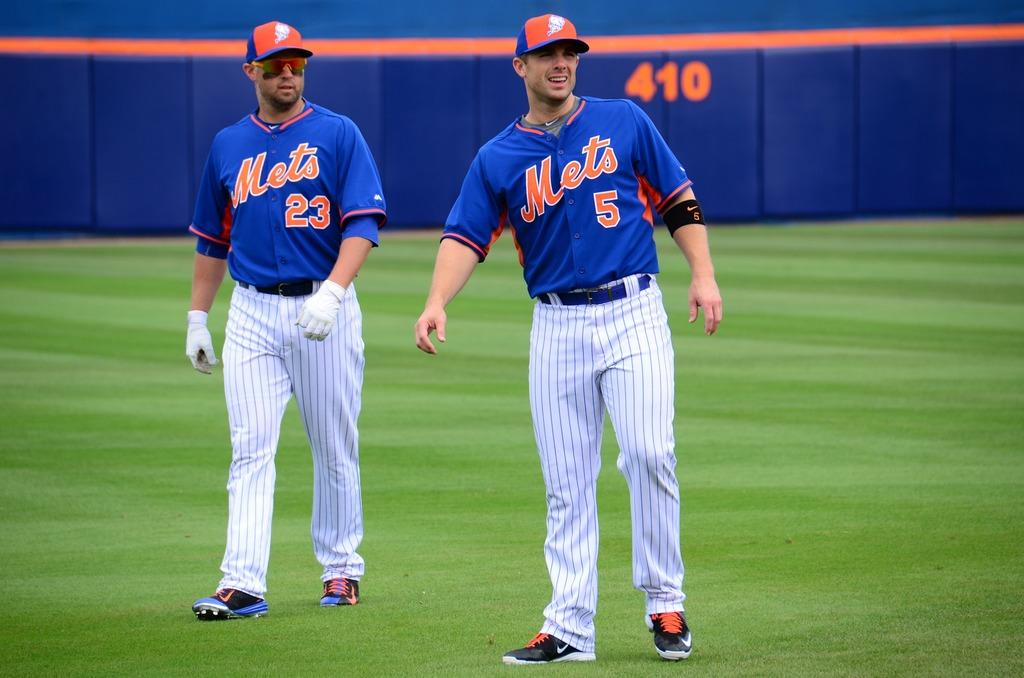<image>
Share a concise interpretation of the image provided. Mets players wearing shirts numbered 23 and 5 walk across the outfield together. 